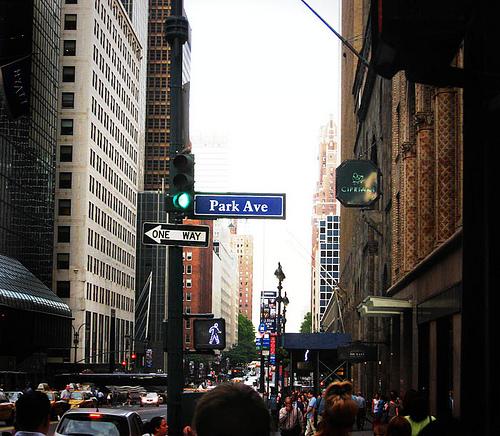Is it daytime?
Concise answer only. Yes. Is the photo in color?
Write a very short answer. Yes. What does the red sign say?
Concise answer only. Stop. What is the top ad for?
Give a very brief answer. Street. What color is the traffic light?
Short answer required. Green. Should people cross in the crosswalk, given the sign that is displayed?
Short answer required. Yes. Is it dark here?
Answer briefly. No. What is the guy in the Red Hat looking at?
Give a very brief answer. Sky. What city is this likely in?
Keep it brief. New york. Is this an overcast day?
Answer briefly. Yes. What do cars do when the traffic light is the color that it is?
Short answer required. Go. What is the name of the Avenue?
Keep it brief. Park. Must the people go the direction of the one way sign?
Be succinct. No. How many people are wearing a Red Hat?
Write a very short answer. 0. Are the signs in English?
Write a very short answer. Yes. Are the signs Asian?
Write a very short answer. No. Is this during the day time?
Answer briefly. Yes. 